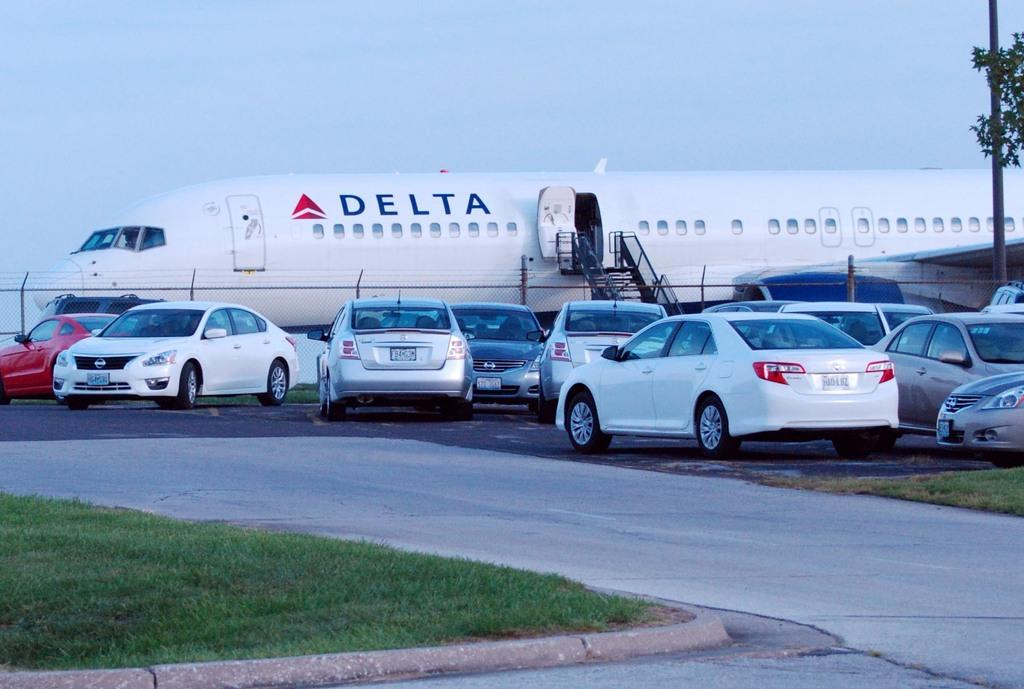What is the main subject of the image? The main subject of the image is cars on a road. What can be seen on either side of the road? There is grassland on either side of the road. What is visible in the background of the image? In the background of the image, there is fencing, an airplane, and the sky. What type of flowers are listed in the image? There are no flowers or lists present in the image. 